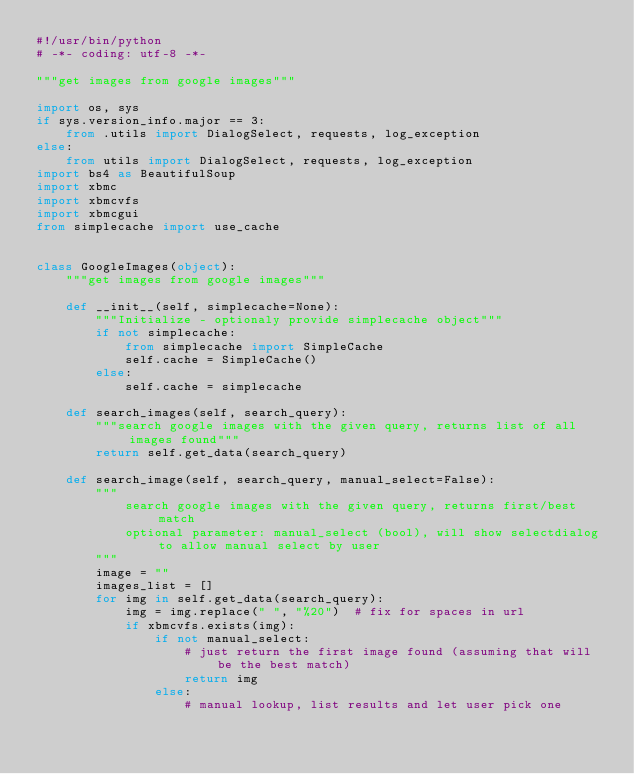<code> <loc_0><loc_0><loc_500><loc_500><_Python_>#!/usr/bin/python
# -*- coding: utf-8 -*-

"""get images from google images"""

import os, sys
if sys.version_info.major == 3:
    from .utils import DialogSelect, requests, log_exception
else:
    from utils import DialogSelect, requests, log_exception
import bs4 as BeautifulSoup
import xbmc
import xbmcvfs
import xbmcgui
from simplecache import use_cache


class GoogleImages(object):
    """get images from google images"""

    def __init__(self, simplecache=None):
        """Initialize - optionaly provide simplecache object"""
        if not simplecache:
            from simplecache import SimpleCache
            self.cache = SimpleCache()
        else:
            self.cache = simplecache

    def search_images(self, search_query):
        """search google images with the given query, returns list of all images found"""
        return self.get_data(search_query)

    def search_image(self, search_query, manual_select=False):
        """
            search google images with the given query, returns first/best match
            optional parameter: manual_select (bool), will show selectdialog to allow manual select by user
        """
        image = ""
        images_list = []
        for img in self.get_data(search_query):
            img = img.replace(" ", "%20")  # fix for spaces in url
            if xbmcvfs.exists(img):
                if not manual_select:
                    # just return the first image found (assuming that will be the best match)
                    return img
                else:
                    # manual lookup, list results and let user pick one</code> 